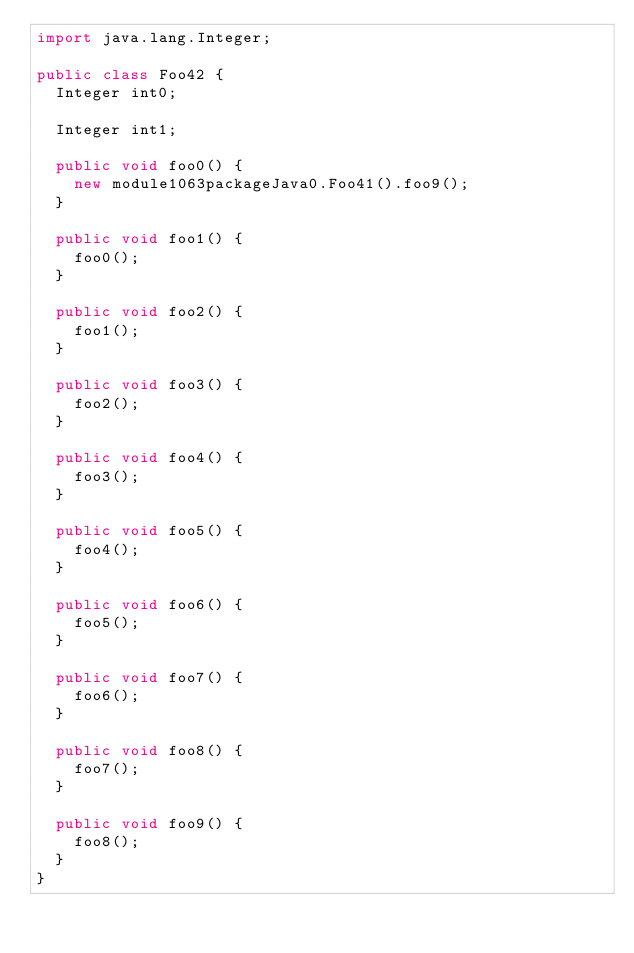<code> <loc_0><loc_0><loc_500><loc_500><_Java_>import java.lang.Integer;

public class Foo42 {
  Integer int0;

  Integer int1;

  public void foo0() {
    new module1063packageJava0.Foo41().foo9();
  }

  public void foo1() {
    foo0();
  }

  public void foo2() {
    foo1();
  }

  public void foo3() {
    foo2();
  }

  public void foo4() {
    foo3();
  }

  public void foo5() {
    foo4();
  }

  public void foo6() {
    foo5();
  }

  public void foo7() {
    foo6();
  }

  public void foo8() {
    foo7();
  }

  public void foo9() {
    foo8();
  }
}
</code> 